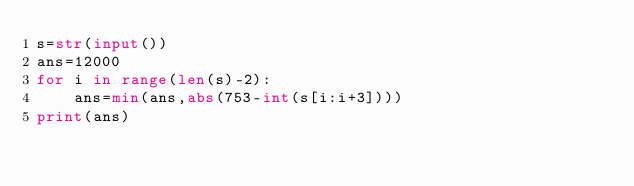<code> <loc_0><loc_0><loc_500><loc_500><_Python_>s=str(input())
ans=12000
for i in range(len(s)-2):
    ans=min(ans,abs(753-int(s[i:i+3])))
print(ans)</code> 